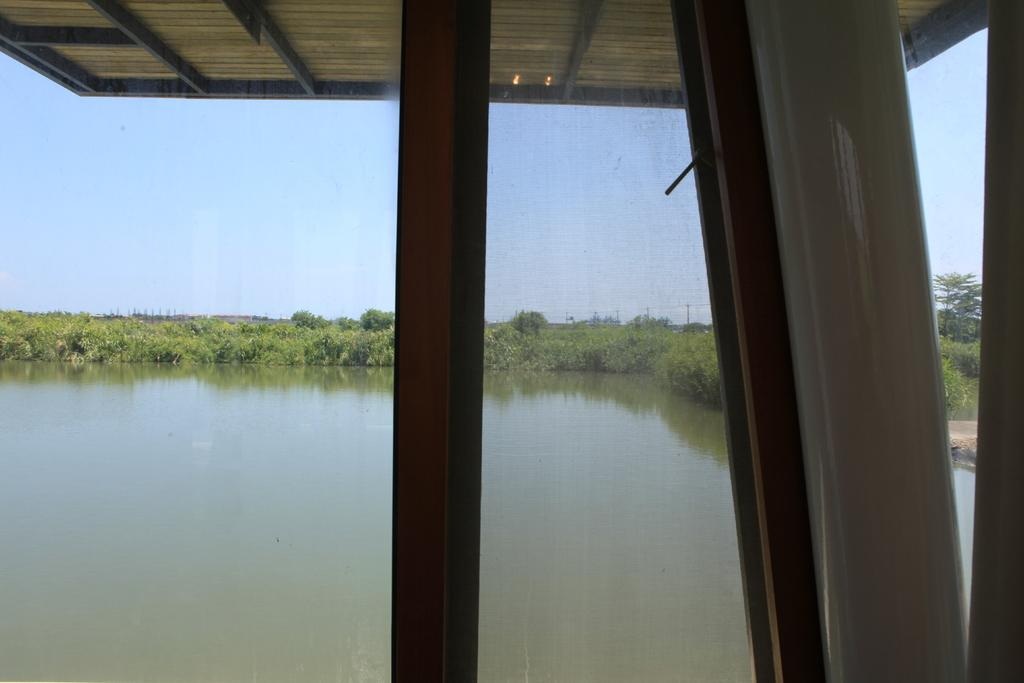What is located in the foreground of the picture? There is a glass in the foreground of the picture. What can be seen in the center of the picture? There are plants, trees, and a water body in the center of the picture. What is the condition of the sky in the picture? The sky is clear in the picture. What is the weather like in the image? It is sunny in the image. Can you see a bridge crossing the water body in the image? There is no bridge visible in the image. Is there a volleyball game happening in the center of the picture? There is no volleyball game present in the image. 